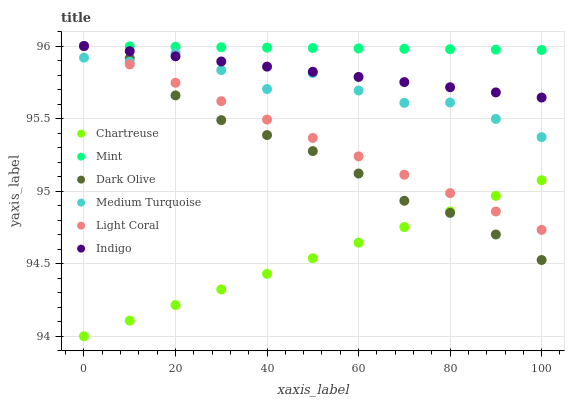Does Chartreuse have the minimum area under the curve?
Answer yes or no. Yes. Does Mint have the maximum area under the curve?
Answer yes or no. Yes. Does Dark Olive have the minimum area under the curve?
Answer yes or no. No. Does Dark Olive have the maximum area under the curve?
Answer yes or no. No. Is Indigo the smoothest?
Answer yes or no. Yes. Is Medium Turquoise the roughest?
Answer yes or no. Yes. Is Dark Olive the smoothest?
Answer yes or no. No. Is Dark Olive the roughest?
Answer yes or no. No. Does Chartreuse have the lowest value?
Answer yes or no. Yes. Does Dark Olive have the lowest value?
Answer yes or no. No. Does Mint have the highest value?
Answer yes or no. Yes. Does Chartreuse have the highest value?
Answer yes or no. No. Is Medium Turquoise less than Mint?
Answer yes or no. Yes. Is Indigo greater than Chartreuse?
Answer yes or no. Yes. Does Chartreuse intersect Light Coral?
Answer yes or no. Yes. Is Chartreuse less than Light Coral?
Answer yes or no. No. Is Chartreuse greater than Light Coral?
Answer yes or no. No. Does Medium Turquoise intersect Mint?
Answer yes or no. No. 